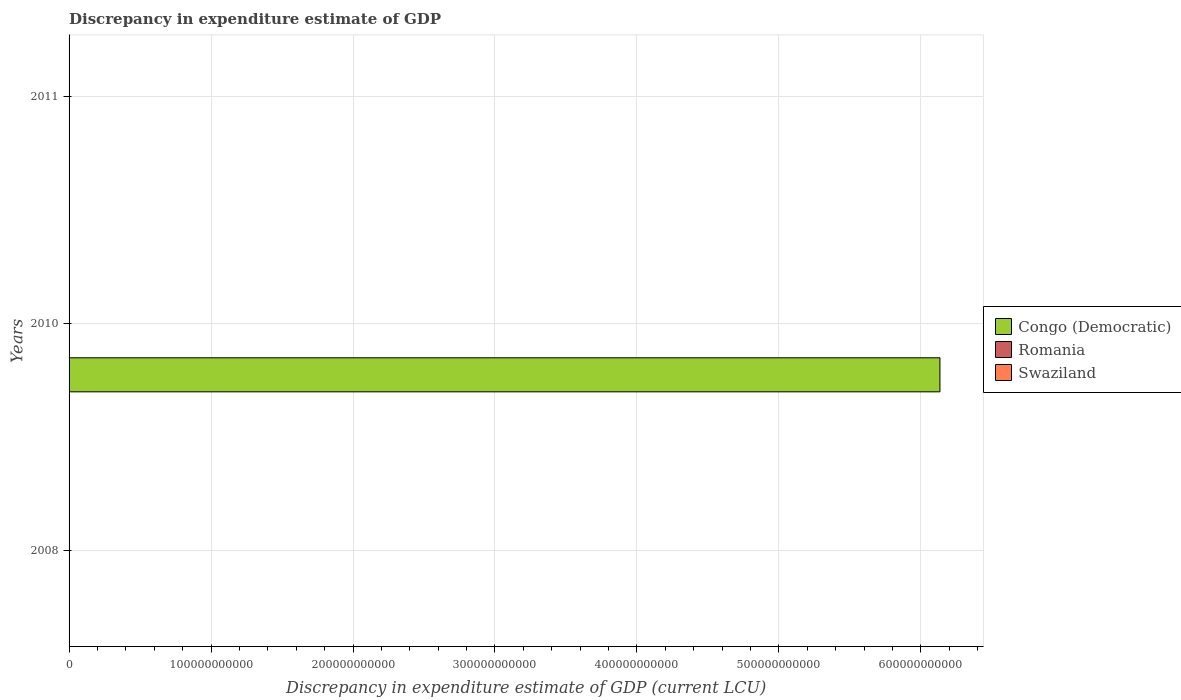Are the number of bars per tick equal to the number of legend labels?
Provide a short and direct response. No. Are the number of bars on each tick of the Y-axis equal?
Provide a succinct answer. No. How many bars are there on the 3rd tick from the top?
Ensure brevity in your answer.  2. How many bars are there on the 3rd tick from the bottom?
Your answer should be very brief. 1. What is the discrepancy in expenditure estimate of GDP in Swaziland in 2011?
Your response must be concise. 4.12e+07. Across all years, what is the maximum discrepancy in expenditure estimate of GDP in Romania?
Your response must be concise. 1.5e-5. In which year was the discrepancy in expenditure estimate of GDP in Swaziland maximum?
Your response must be concise. 2011. What is the total discrepancy in expenditure estimate of GDP in Romania in the graph?
Ensure brevity in your answer.  1.5e-5. What is the difference between the discrepancy in expenditure estimate of GDP in Congo (Democratic) in 2008 and that in 2010?
Provide a succinct answer. -6.13e+11. What is the difference between the discrepancy in expenditure estimate of GDP in Congo (Democratic) in 2010 and the discrepancy in expenditure estimate of GDP in Swaziland in 2008?
Provide a short and direct response. 6.13e+11. What is the average discrepancy in expenditure estimate of GDP in Congo (Democratic) per year?
Keep it short and to the point. 2.04e+11. In the year 2010, what is the difference between the discrepancy in expenditure estimate of GDP in Congo (Democratic) and discrepancy in expenditure estimate of GDP in Romania?
Keep it short and to the point. 6.13e+11. In how many years, is the discrepancy in expenditure estimate of GDP in Congo (Democratic) greater than 120000000000 LCU?
Keep it short and to the point. 1. What is the ratio of the discrepancy in expenditure estimate of GDP in Congo (Democratic) in 2008 to that in 2010?
Give a very brief answer. 1.629838583318674e-11. What is the difference between the highest and the lowest discrepancy in expenditure estimate of GDP in Congo (Democratic)?
Keep it short and to the point. 6.13e+11. In how many years, is the discrepancy in expenditure estimate of GDP in Swaziland greater than the average discrepancy in expenditure estimate of GDP in Swaziland taken over all years?
Provide a short and direct response. 1. What is the difference between two consecutive major ticks on the X-axis?
Your answer should be compact. 1.00e+11. Are the values on the major ticks of X-axis written in scientific E-notation?
Your answer should be very brief. No. How many legend labels are there?
Offer a very short reply. 3. How are the legend labels stacked?
Your response must be concise. Vertical. What is the title of the graph?
Your response must be concise. Discrepancy in expenditure estimate of GDP. What is the label or title of the X-axis?
Offer a terse response. Discrepancy in expenditure estimate of GDP (current LCU). What is the Discrepancy in expenditure estimate of GDP (current LCU) in Congo (Democratic) in 2008?
Provide a short and direct response. 10. What is the Discrepancy in expenditure estimate of GDP (current LCU) of Swaziland in 2008?
Provide a succinct answer. 1.00e+05. What is the Discrepancy in expenditure estimate of GDP (current LCU) in Congo (Democratic) in 2010?
Keep it short and to the point. 6.13e+11. What is the Discrepancy in expenditure estimate of GDP (current LCU) in Romania in 2010?
Your answer should be compact. 1.5e-5. What is the Discrepancy in expenditure estimate of GDP (current LCU) of Swaziland in 2010?
Give a very brief answer. 0. What is the Discrepancy in expenditure estimate of GDP (current LCU) in Romania in 2011?
Offer a very short reply. 0. What is the Discrepancy in expenditure estimate of GDP (current LCU) of Swaziland in 2011?
Offer a terse response. 4.12e+07. Across all years, what is the maximum Discrepancy in expenditure estimate of GDP (current LCU) in Congo (Democratic)?
Ensure brevity in your answer.  6.13e+11. Across all years, what is the maximum Discrepancy in expenditure estimate of GDP (current LCU) of Romania?
Keep it short and to the point. 1.5e-5. Across all years, what is the maximum Discrepancy in expenditure estimate of GDP (current LCU) in Swaziland?
Your response must be concise. 4.12e+07. Across all years, what is the minimum Discrepancy in expenditure estimate of GDP (current LCU) in Congo (Democratic)?
Keep it short and to the point. 0. Across all years, what is the minimum Discrepancy in expenditure estimate of GDP (current LCU) in Swaziland?
Your answer should be compact. 0. What is the total Discrepancy in expenditure estimate of GDP (current LCU) of Congo (Democratic) in the graph?
Offer a very short reply. 6.13e+11. What is the total Discrepancy in expenditure estimate of GDP (current LCU) in Swaziland in the graph?
Your response must be concise. 4.13e+07. What is the difference between the Discrepancy in expenditure estimate of GDP (current LCU) in Congo (Democratic) in 2008 and that in 2010?
Keep it short and to the point. -6.13e+11. What is the difference between the Discrepancy in expenditure estimate of GDP (current LCU) of Swaziland in 2008 and that in 2011?
Offer a very short reply. -4.11e+07. What is the difference between the Discrepancy in expenditure estimate of GDP (current LCU) of Congo (Democratic) in 2008 and the Discrepancy in expenditure estimate of GDP (current LCU) of Romania in 2010?
Your response must be concise. 10. What is the difference between the Discrepancy in expenditure estimate of GDP (current LCU) of Congo (Democratic) in 2008 and the Discrepancy in expenditure estimate of GDP (current LCU) of Swaziland in 2011?
Keep it short and to the point. -4.12e+07. What is the difference between the Discrepancy in expenditure estimate of GDP (current LCU) in Congo (Democratic) in 2010 and the Discrepancy in expenditure estimate of GDP (current LCU) in Swaziland in 2011?
Your answer should be compact. 6.13e+11. What is the difference between the Discrepancy in expenditure estimate of GDP (current LCU) in Romania in 2010 and the Discrepancy in expenditure estimate of GDP (current LCU) in Swaziland in 2011?
Provide a short and direct response. -4.12e+07. What is the average Discrepancy in expenditure estimate of GDP (current LCU) in Congo (Democratic) per year?
Keep it short and to the point. 2.04e+11. What is the average Discrepancy in expenditure estimate of GDP (current LCU) of Swaziland per year?
Give a very brief answer. 1.38e+07. In the year 2008, what is the difference between the Discrepancy in expenditure estimate of GDP (current LCU) of Congo (Democratic) and Discrepancy in expenditure estimate of GDP (current LCU) of Swaziland?
Provide a short and direct response. -1.00e+05. In the year 2010, what is the difference between the Discrepancy in expenditure estimate of GDP (current LCU) in Congo (Democratic) and Discrepancy in expenditure estimate of GDP (current LCU) in Romania?
Your answer should be compact. 6.13e+11. What is the ratio of the Discrepancy in expenditure estimate of GDP (current LCU) of Swaziland in 2008 to that in 2011?
Offer a very short reply. 0. What is the difference between the highest and the lowest Discrepancy in expenditure estimate of GDP (current LCU) of Congo (Democratic)?
Your answer should be compact. 6.13e+11. What is the difference between the highest and the lowest Discrepancy in expenditure estimate of GDP (current LCU) in Swaziland?
Offer a very short reply. 4.12e+07. 